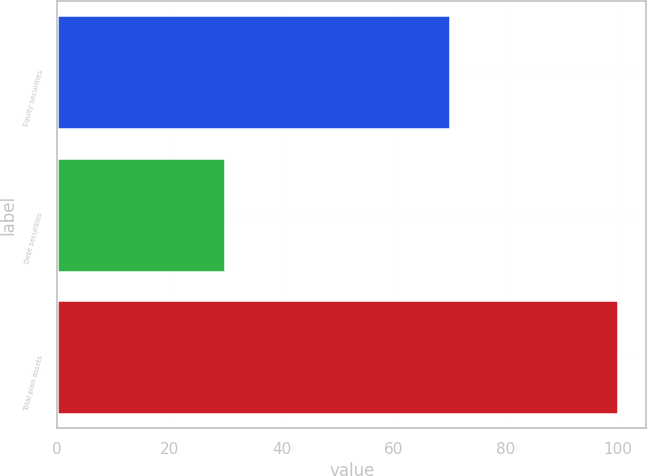Convert chart. <chart><loc_0><loc_0><loc_500><loc_500><bar_chart><fcel>Equity securities<fcel>Debt securities<fcel>Total plan assets<nl><fcel>70<fcel>30<fcel>100<nl></chart> 